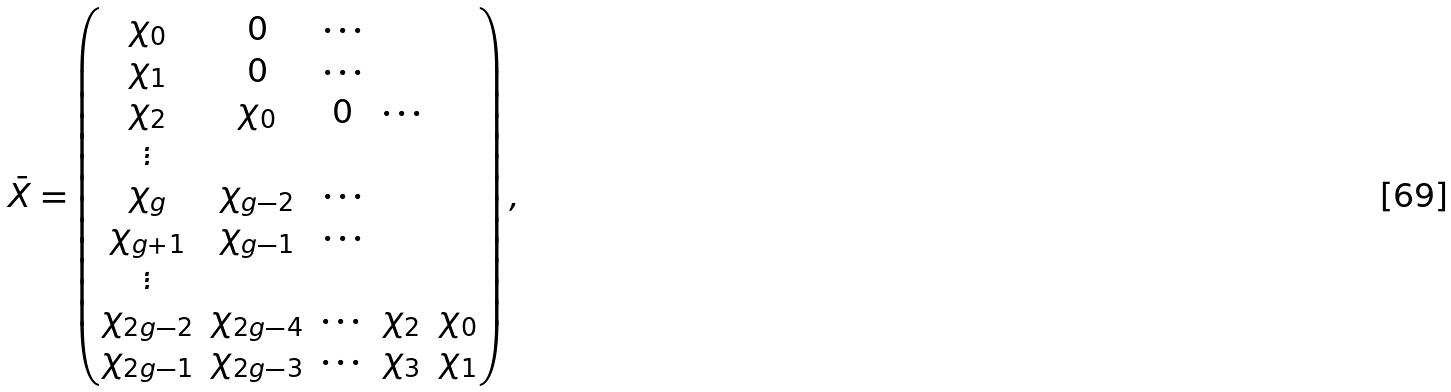<formula> <loc_0><loc_0><loc_500><loc_500>\bar { X } = \begin{pmatrix} \chi _ { 0 } & 0 & \cdots \\ \chi _ { 1 } & 0 & \cdots \\ \chi _ { 2 } & \chi _ { 0 } & 0 & \cdots \\ \vdots \\ \chi _ { g } & \chi _ { g - 2 } & \cdots \\ \chi _ { g + 1 } & \chi _ { g - 1 } & \cdots \\ \vdots \\ \chi _ { 2 g - 2 } & \chi _ { 2 g - 4 } & \cdots & \chi _ { 2 } & \chi _ { 0 } \\ \chi _ { 2 g - 1 } & \chi _ { 2 g - 3 } & \cdots & \chi _ { 3 } & \chi _ { 1 } \\ \end{pmatrix} ,</formula> 